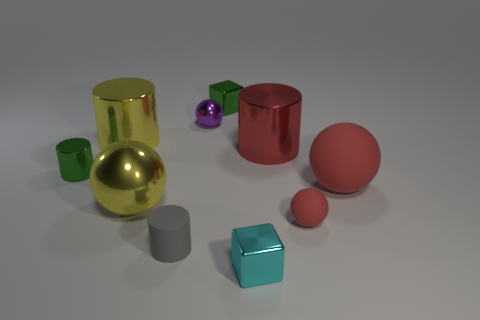Are there any small things of the same color as the tiny rubber sphere?
Offer a terse response. No. There is a matte cylinder; does it have the same size as the green metallic thing that is to the left of the gray object?
Offer a terse response. Yes. There is a small cylinder in front of the big sphere behind the yellow ball; how many tiny gray cylinders are left of it?
Give a very brief answer. 0. There is another rubber object that is the same color as the large matte thing; what size is it?
Provide a short and direct response. Small. There is a purple metallic ball; are there any large red spheres to the left of it?
Your answer should be very brief. No. What is the shape of the gray rubber object?
Give a very brief answer. Cylinder. There is a large yellow shiny object that is in front of the green metal object that is in front of the small sphere that is behind the tiny red matte object; what shape is it?
Your response must be concise. Sphere. How many other objects are the same shape as the purple thing?
Keep it short and to the point. 3. There is a cylinder that is in front of the large sphere that is to the left of the small cyan shiny object; what is its material?
Give a very brief answer. Rubber. Is there any other thing that is the same size as the green cylinder?
Offer a terse response. Yes. 